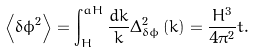Convert formula to latex. <formula><loc_0><loc_0><loc_500><loc_500>\left < { \delta \phi } ^ { 2 } \right > = \int _ { H } ^ { a H } { \frac { d k } { k } } { \Delta } _ { \delta \phi } ^ { 2 } \left ( k \right ) = \frac { { H } ^ { 3 } } { { 4 { \pi } ^ { 2 } } } t .</formula> 